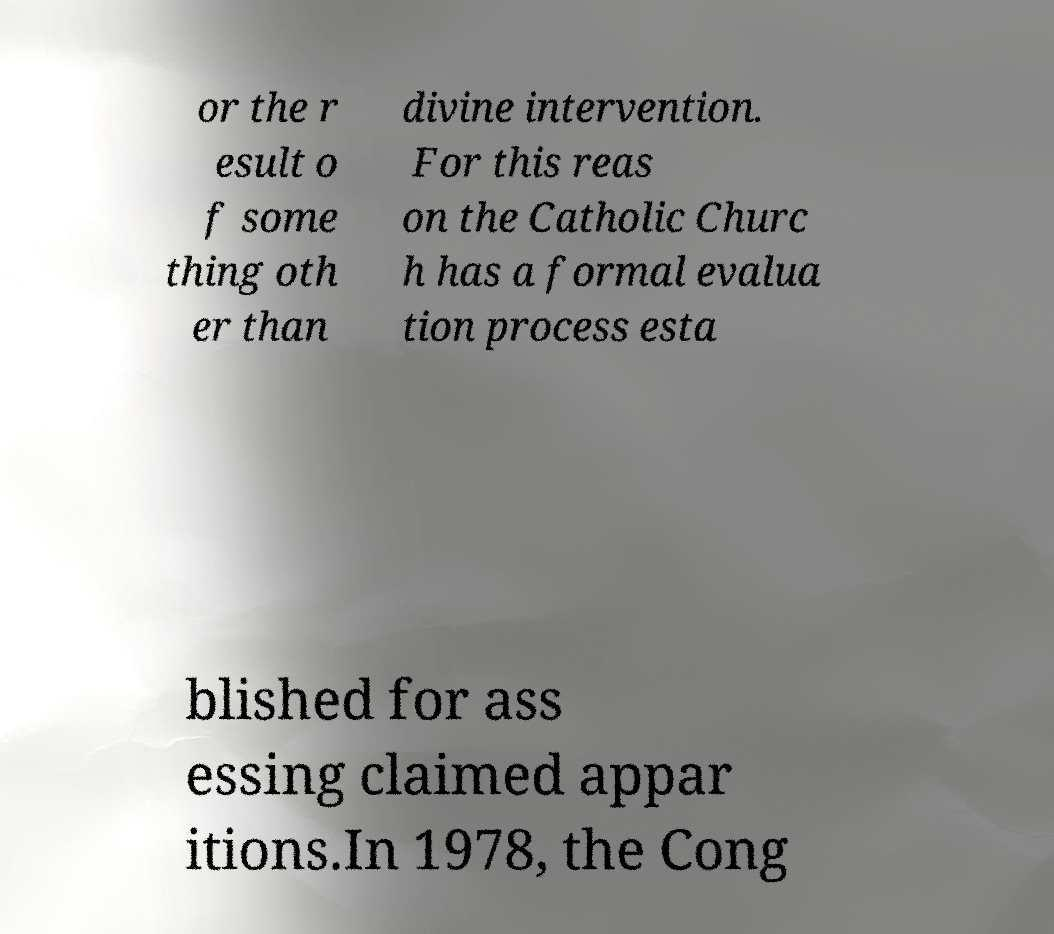Please identify and transcribe the text found in this image. or the r esult o f some thing oth er than divine intervention. For this reas on the Catholic Churc h has a formal evalua tion process esta blished for ass essing claimed appar itions.In 1978, the Cong 